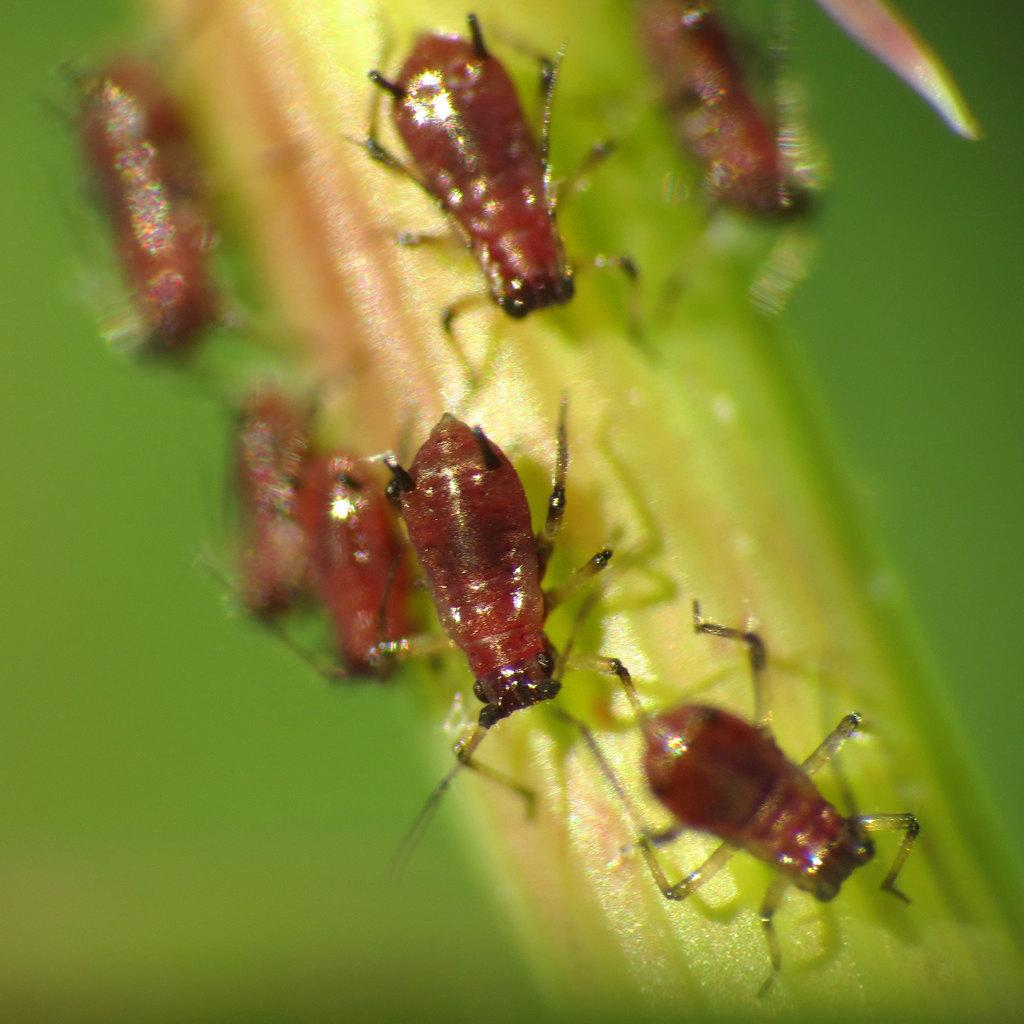What color is the main object in the image? The main object in the image is green. What is present on the green object? There are brown insects on the green object. How would you describe the clarity of the image? The image is slightly blurry. What type of meat is being served on the linen tablecloth in the image? There is no meat or linen tablecloth present in the image; it features a green object with brown insects on it. 